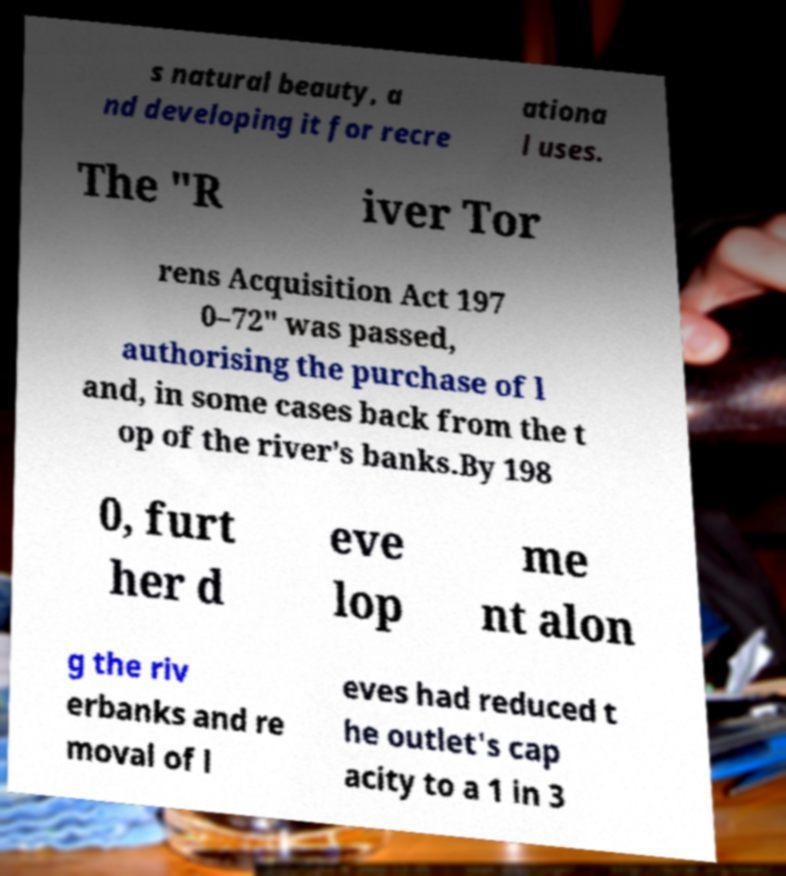Can you read and provide the text displayed in the image?This photo seems to have some interesting text. Can you extract and type it out for me? s natural beauty, a nd developing it for recre ationa l uses. The "R iver Tor rens Acquisition Act 197 0–72" was passed, authorising the purchase of l and, in some cases back from the t op of the river's banks.By 198 0, furt her d eve lop me nt alon g the riv erbanks and re moval of l eves had reduced t he outlet's cap acity to a 1 in 3 